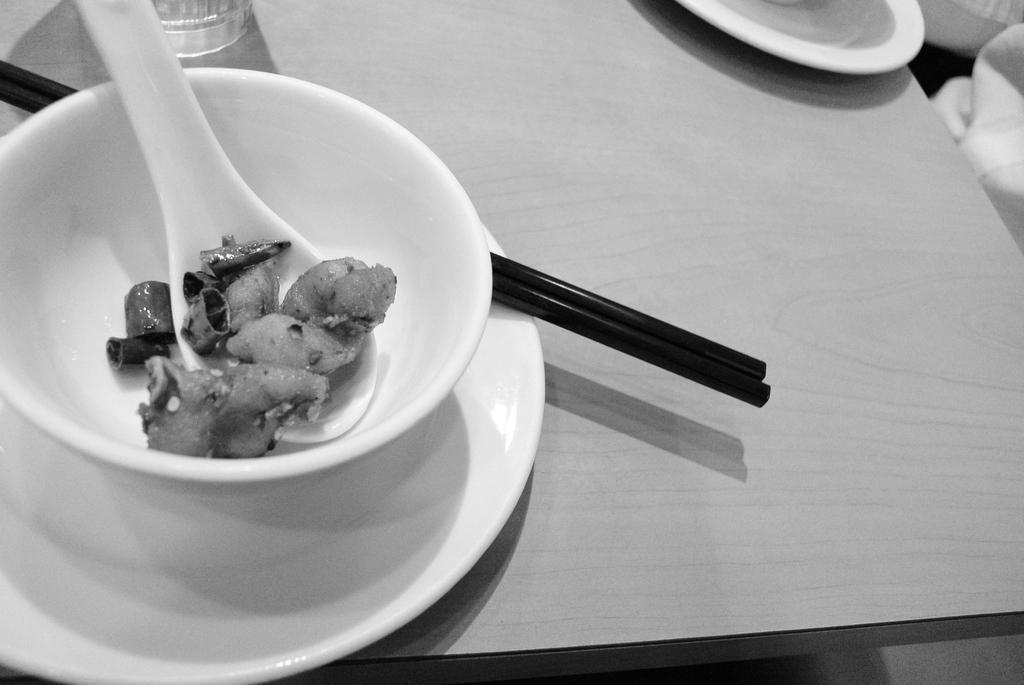Can you describe this image briefly? in this image there is food , spoon , bowl , plate , chopsticks, glass in table. 